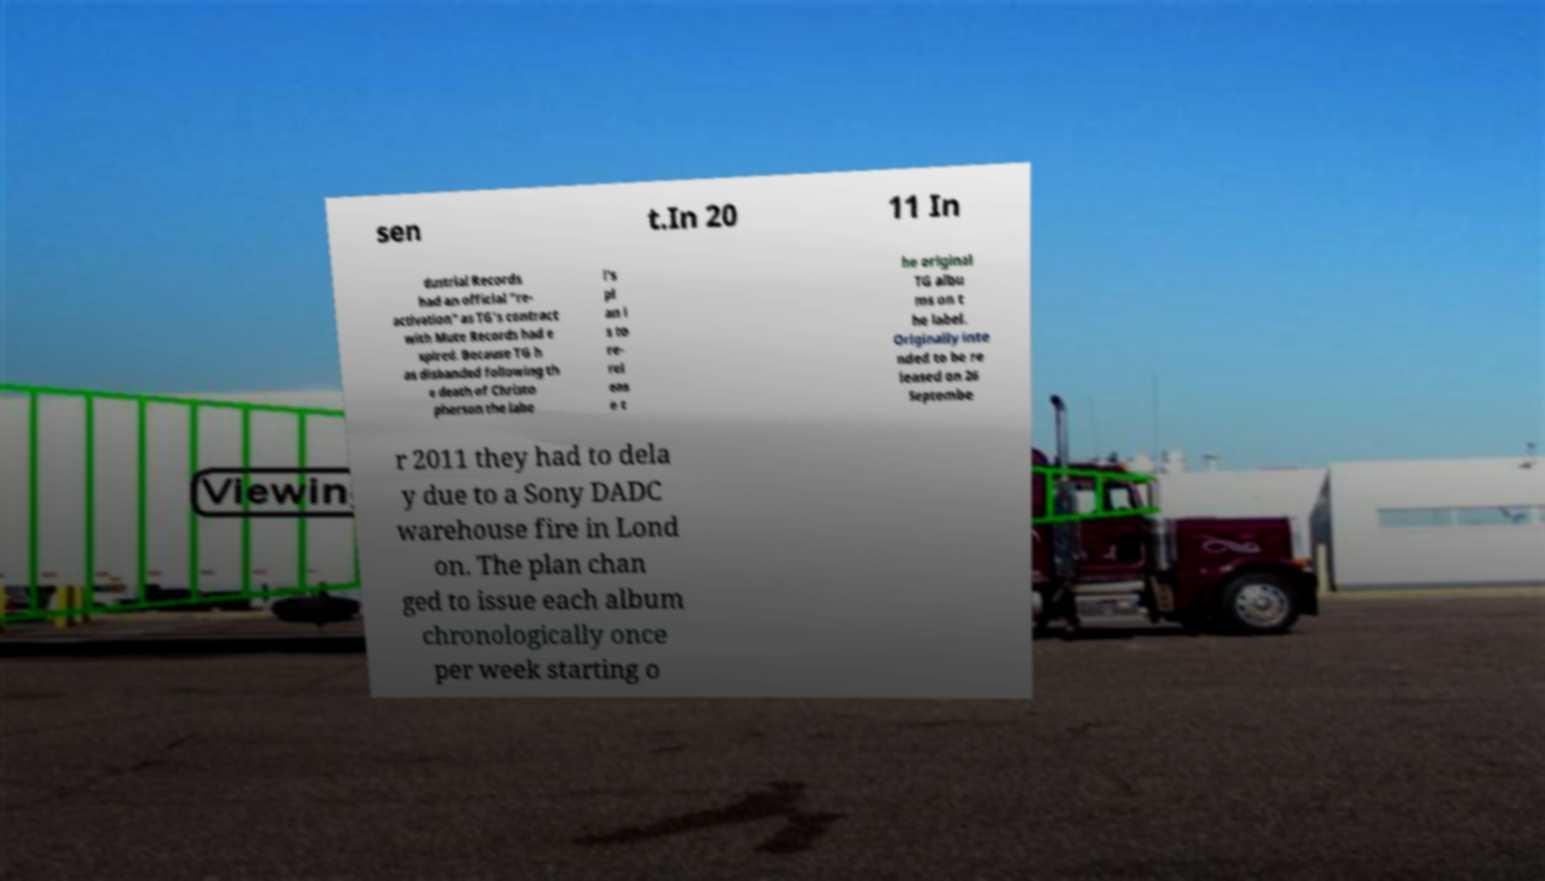Could you assist in decoding the text presented in this image and type it out clearly? sen t.In 20 11 In dustrial Records had an official "re- activation" as TG's contract with Mute Records had e xpired. Because TG h as disbanded following th e death of Christo pherson the labe l's pl an i s to re- rel eas e t he original TG albu ms on t he label. Originally inte nded to be re leased on 26 Septembe r 2011 they had to dela y due to a Sony DADC warehouse fire in Lond on. The plan chan ged to issue each album chronologically once per week starting o 